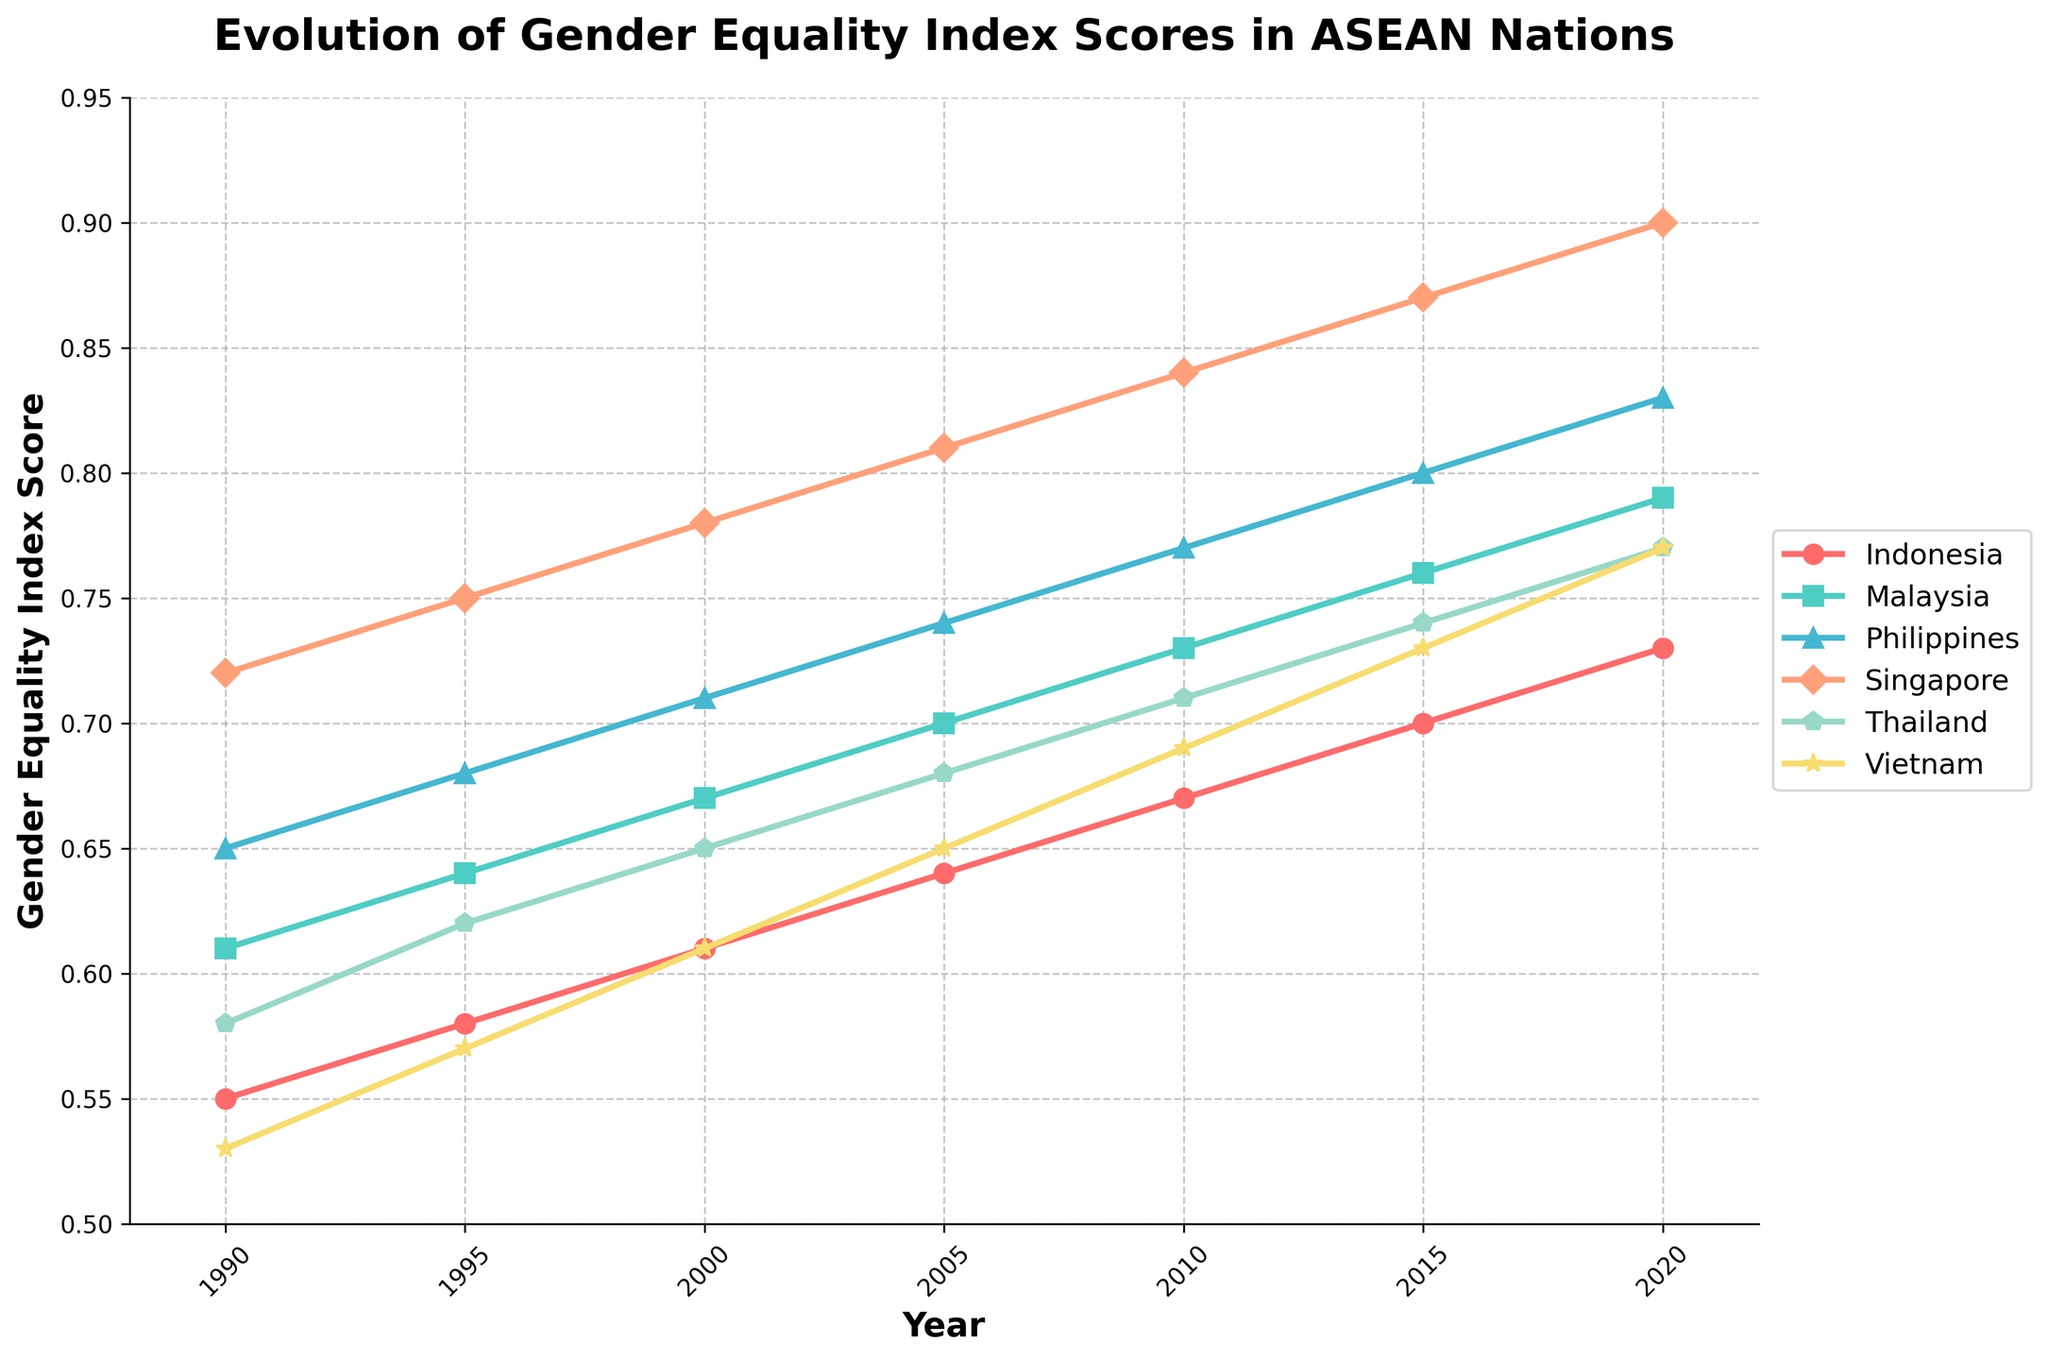What trend can be observed in the Gender Equality Index scores for the Philippines from 1990 to 2020? The trend for the Philippines shows a steady and consistent increase in its Gender Equality Index score over the 30-year period, starting from 0.65 in 1990 and rising to 0.83 in 2020.
Answer: Steady increase Which ASEAN nation had the highest Gender Equality Index score in 2020? In 2020, Singapore had the highest Gender Equality Index score among the ASEAN nations listed, with a score of 0.90.
Answer: Singapore How did Malaysia's Gender Equality Index score change from 2000 to 2010? Malaysia's Gender Equality Index score increased from 0.67 in 2000 to 0.73 in 2010. By subtraction, the change is 0.73 - 0.67 = 0.06.
Answer: +0.06 Which country showed the largest improvement in its Gender Equality Index score from 1990 to 2020? Comparing the starting and ending scores for each country: Indonesia (0.55 to 0.73), Malaysia (0.61 to 0.79), Philippines (0.65 to 0.83), Singapore (0.72 to 0.90), Thailand (0.58 to 0.77), Vietnam (0.53 to 0.77), Singapore showed the largest improvement with an increase of 0.18.
Answer: Singapore In which year did Indonesia surpass the 0.60 mark in its Gender Equality Index score? Indonesia surpassed the 0.60 mark in the year 2000, as its score reached 0.61.
Answer: 2000 Which two countries have consistently improved at the same rate over the entire period? To determine the rate of improvement, calculate the difference between the 1990 and 2020 scores for each country. Both Malaysia and the Philippines improved their scores by 0.18 points over the period (0.79 - 0.61 = 0.18 for Malaysia and 0.83 - 0.65 = 0.18 for the Philippines).
Answer: Malaysia and Philippines In 2015, which country's index score was equal to the Philippines' score in 2010? In 2015, Vietnam's index score was 0.73, which equals the Philippines' score in 2010.
Answer: Vietnam How many countries had a Gender Equality Index score of 0.70 or higher in the year 2000? In 2000, the countries with index scores of 0.70 or higher were the Philippines (0.71) and Singapore (0.78). Thus, only two countries had scores of 0.70 or higher.
Answer: 2 What is the average Gender Equality Index score for Thailand over the period 1990-2020? To find the average score for Thailand, sum its scores over the years (0.58 + 0.62 + 0.65 + 0.68 + 0.71 + 0.74 + 0.77) = 4.75. There are 7 data points, so divide the total by 7: 4.75 / 7 ≈ 0.68.
Answer: 0.68 Which country had the smallest increase in Gender Equality Index score from 1990 to 2000? Calculating the changes from 1990 to 2000 for each country, Indonesia increased by 0.06, Malaysia by 0.06, Philippines by 0.06, Singapore by 0.06, Thailand by 0.07, Vietnam by 0.08. The smallest increase occurs for Indonesia, Malaysia, Philippines, and Singapore, all of which had an increase of 0.06.
Answer: Indonesia, Malaysia, Philippines, Singapore 